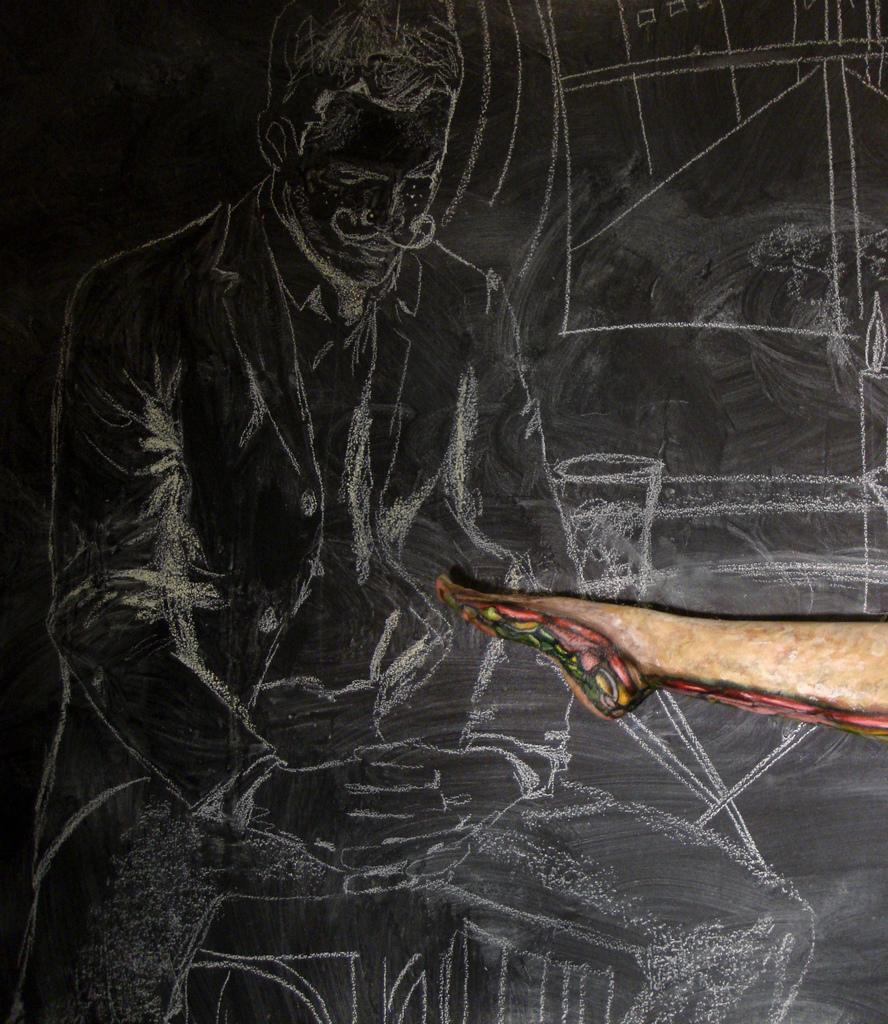Could you give a brief overview of what you see in this image? In this image we can see a man sketch on the black surface. There is a human leg on the right side of the image. 